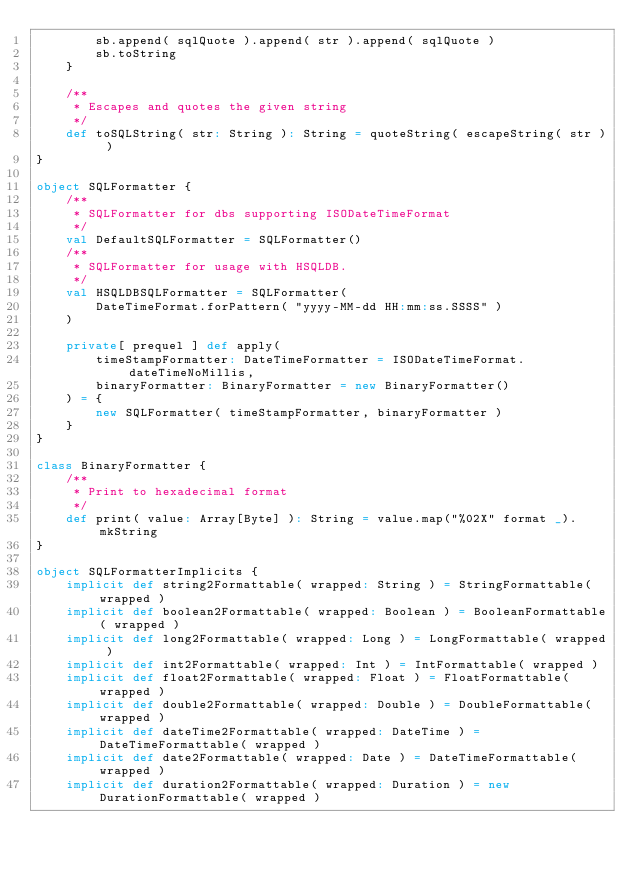Convert code to text. <code><loc_0><loc_0><loc_500><loc_500><_Scala_>        sb.append( sqlQuote ).append( str ).append( sqlQuote )
        sb.toString
    }
    
    /**
     * Escapes and quotes the given string
     */
    def toSQLString( str: String ): String = quoteString( escapeString( str ) )
}

object SQLFormatter {
    /**
     * SQLFormatter for dbs supporting ISODateTimeFormat
     */
    val DefaultSQLFormatter = SQLFormatter()
    /**
     * SQLFormatter for usage with HSQLDB. 
     */
    val HSQLDBSQLFormatter = SQLFormatter(
        DateTimeFormat.forPattern( "yyyy-MM-dd HH:mm:ss.SSSS" )
    )
        
    private[ prequel ] def apply( 
        timeStampFormatter: DateTimeFormatter = ISODateTimeFormat.dateTimeNoMillis,
        binaryFormatter: BinaryFormatter = new BinaryFormatter()
    ) = {
        new SQLFormatter( timeStampFormatter, binaryFormatter )
    }
}

class BinaryFormatter {
    /**
     * Print to hexadecimal format
     */
    def print( value: Array[Byte] ): String = value.map("%02X" format _).mkString
}

object SQLFormatterImplicits {
    implicit def string2Formattable( wrapped: String ) = StringFormattable( wrapped )
    implicit def boolean2Formattable( wrapped: Boolean ) = BooleanFormattable( wrapped )
    implicit def long2Formattable( wrapped: Long ) = LongFormattable( wrapped )
    implicit def int2Formattable( wrapped: Int ) = IntFormattable( wrapped )
    implicit def float2Formattable( wrapped: Float ) = FloatFormattable( wrapped )
    implicit def double2Formattable( wrapped: Double ) = DoubleFormattable( wrapped )
    implicit def dateTime2Formattable( wrapped: DateTime ) = DateTimeFormattable( wrapped )
    implicit def date2Formattable( wrapped: Date ) = DateTimeFormattable( wrapped )
    implicit def duration2Formattable( wrapped: Duration ) = new DurationFormattable( wrapped )</code> 